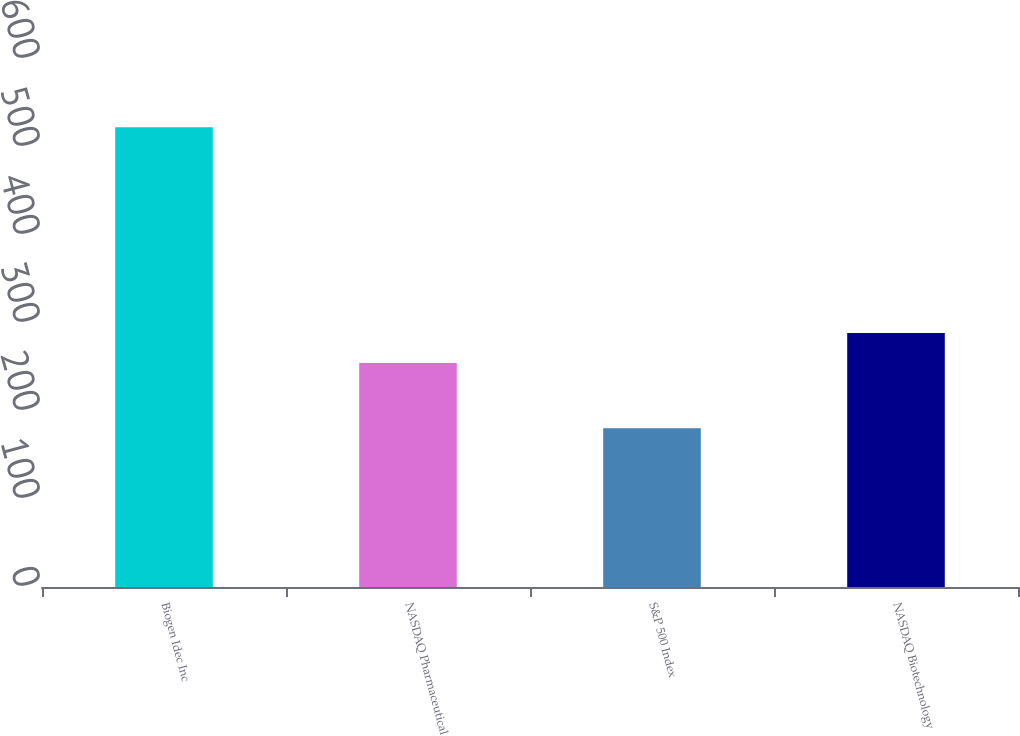<chart> <loc_0><loc_0><loc_500><loc_500><bar_chart><fcel>Biogen Idec Inc<fcel>NASDAQ Pharmaceutical<fcel>S&P 500 Index<fcel>NASDAQ Biotechnology<nl><fcel>522.56<fcel>254.51<fcel>180.44<fcel>288.72<nl></chart> 